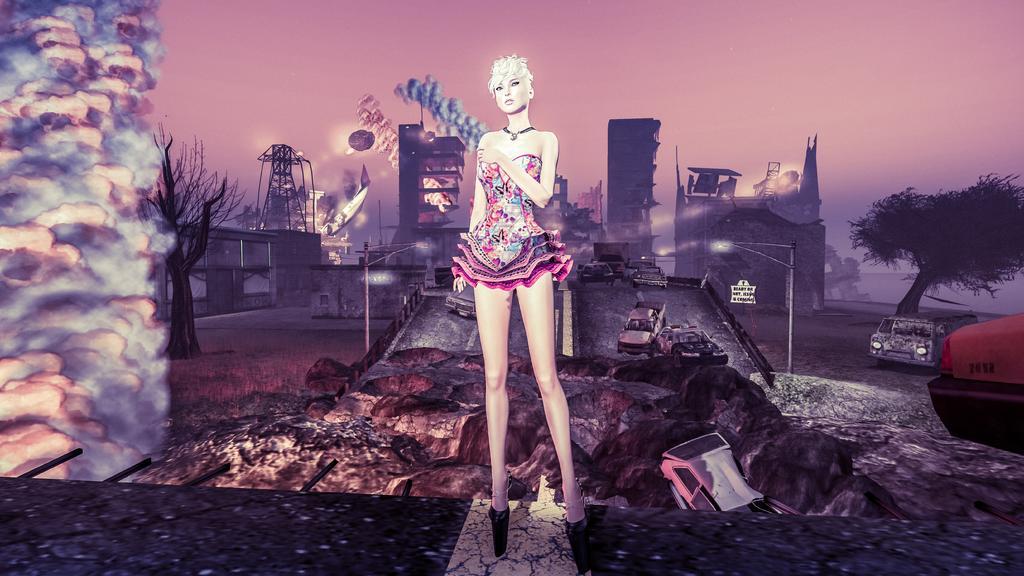In one or two sentences, can you explain what this image depicts? This is a animated picture and in the foreground of this image, we see a woman in single piece dress and wearing high heels. In then background, we see trees, a tower, building, smoke, vehicles, street pole, a name board, and the sky. 